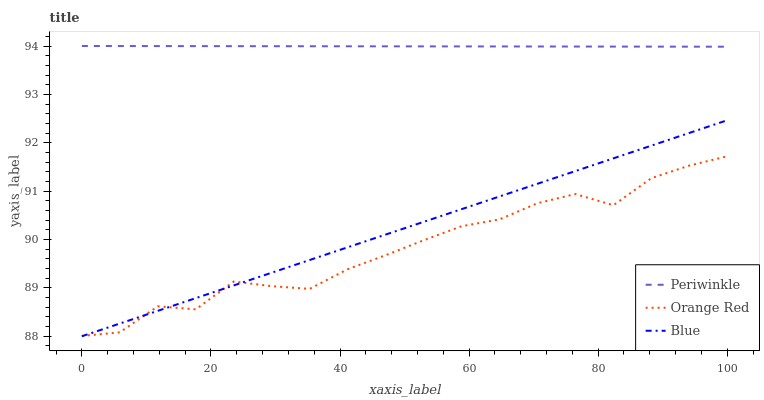Does Orange Red have the minimum area under the curve?
Answer yes or no. Yes. Does Periwinkle have the maximum area under the curve?
Answer yes or no. Yes. Does Periwinkle have the minimum area under the curve?
Answer yes or no. No. Does Orange Red have the maximum area under the curve?
Answer yes or no. No. Is Periwinkle the smoothest?
Answer yes or no. Yes. Is Orange Red the roughest?
Answer yes or no. Yes. Is Orange Red the smoothest?
Answer yes or no. No. Is Periwinkle the roughest?
Answer yes or no. No. Does Blue have the lowest value?
Answer yes or no. Yes. Does Orange Red have the lowest value?
Answer yes or no. No. Does Periwinkle have the highest value?
Answer yes or no. Yes. Does Orange Red have the highest value?
Answer yes or no. No. Is Blue less than Periwinkle?
Answer yes or no. Yes. Is Periwinkle greater than Orange Red?
Answer yes or no. Yes. Does Blue intersect Orange Red?
Answer yes or no. Yes. Is Blue less than Orange Red?
Answer yes or no. No. Is Blue greater than Orange Red?
Answer yes or no. No. Does Blue intersect Periwinkle?
Answer yes or no. No. 